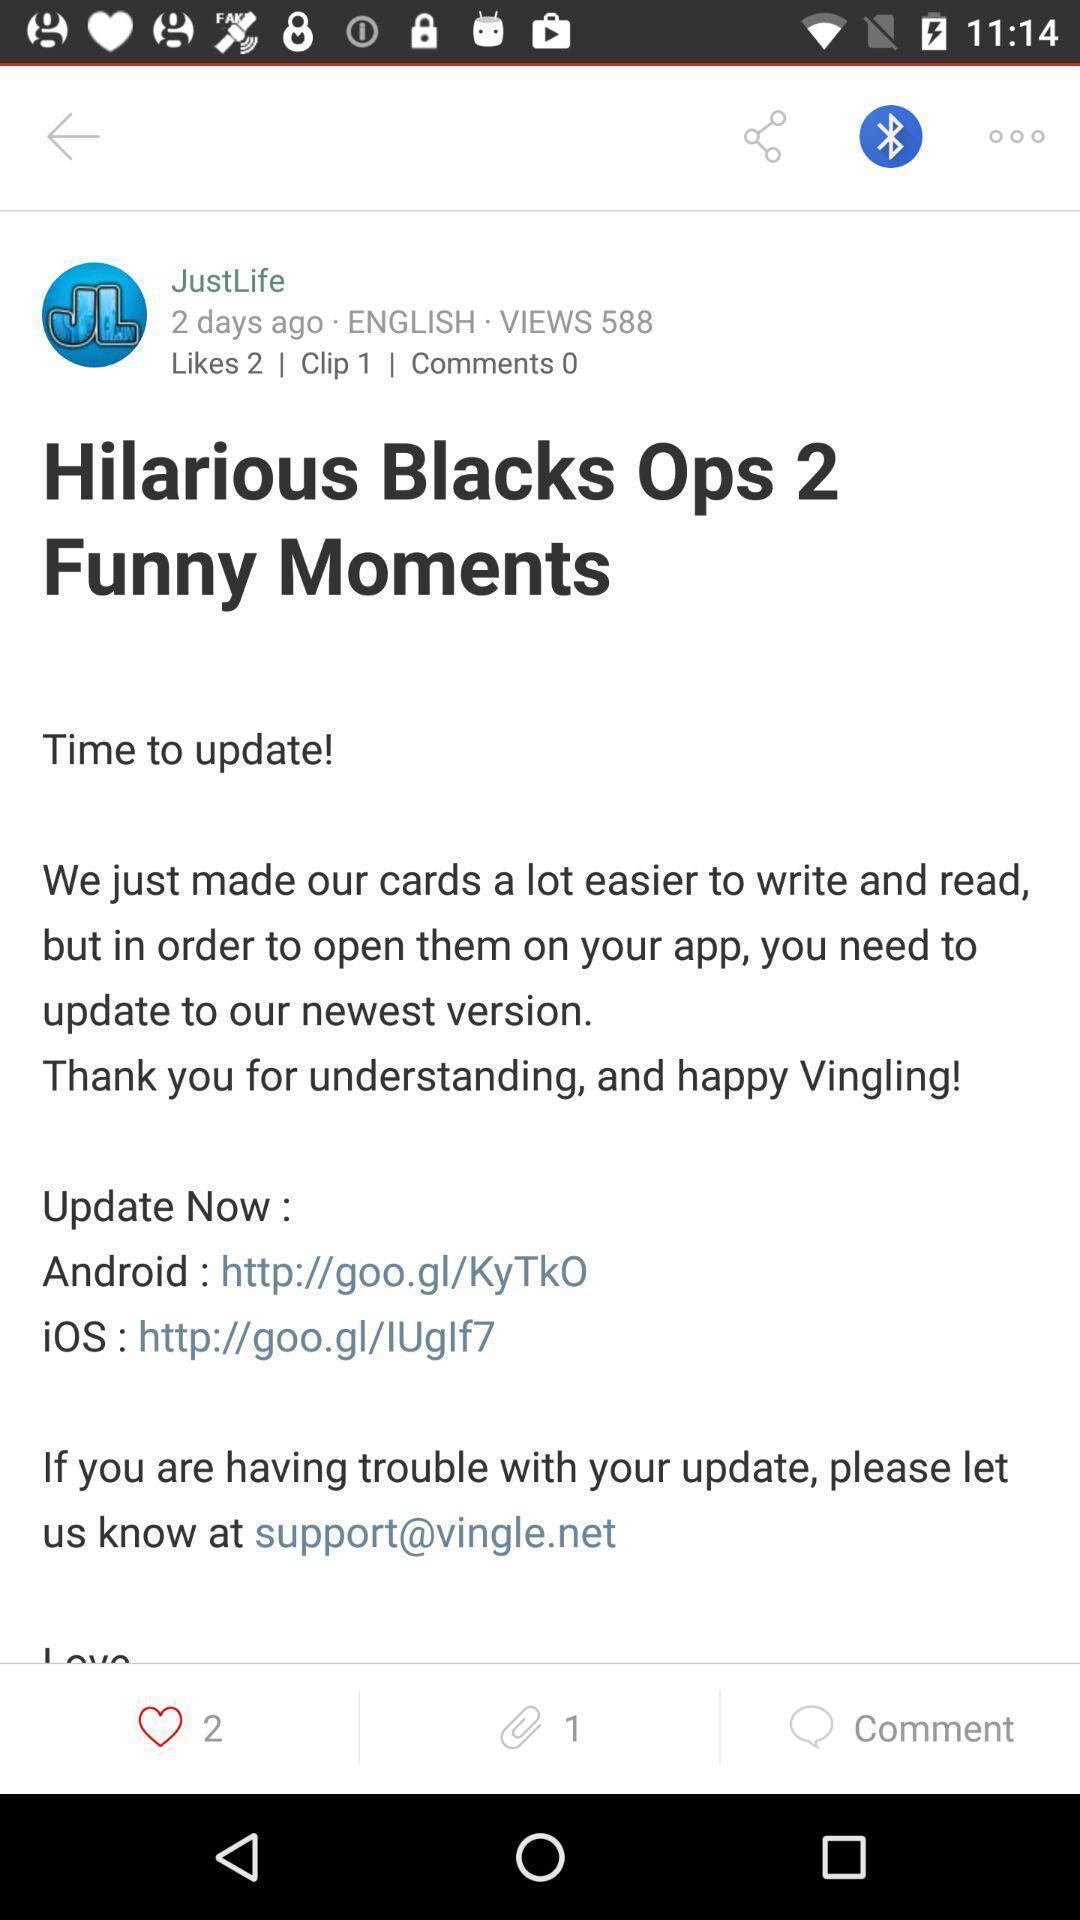Describe the visual elements of this screenshot. Page displaying to upgrade. 